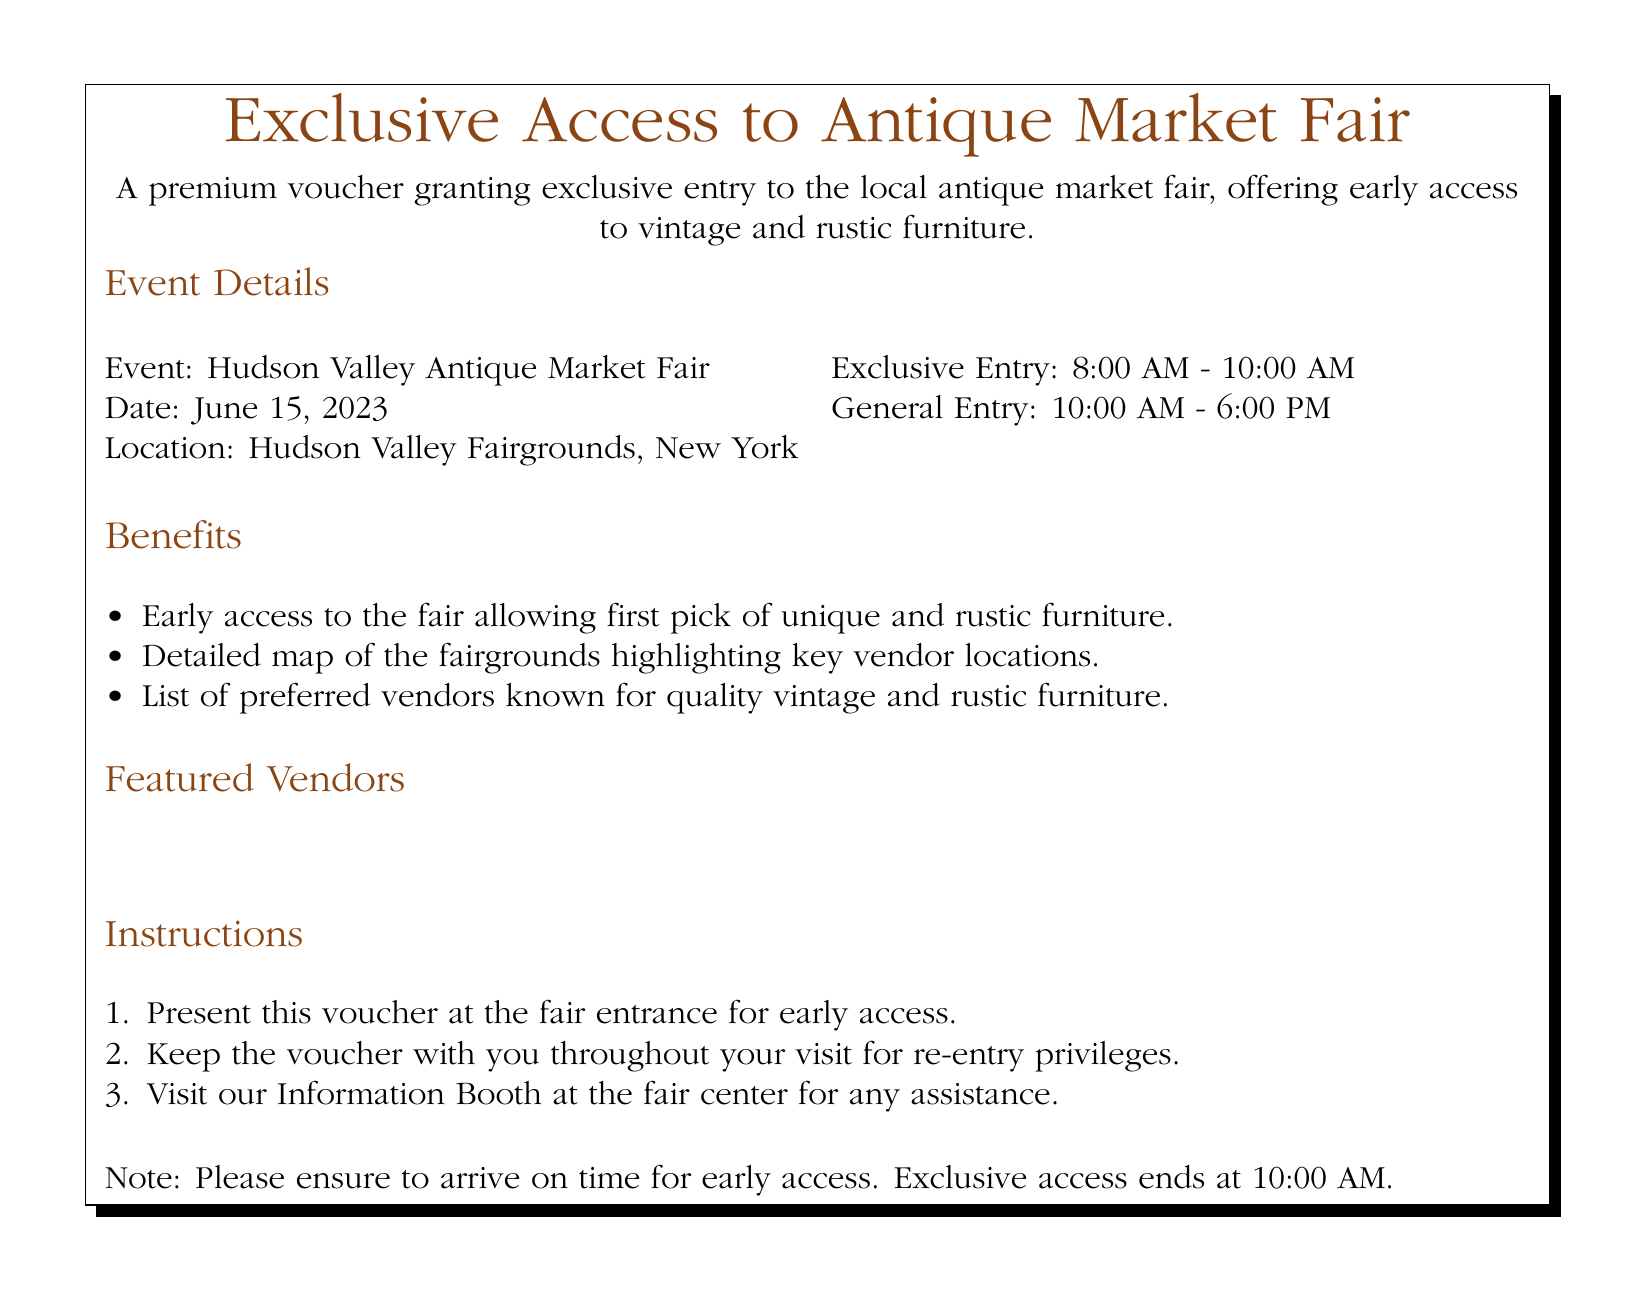What is the event name? The event name is clearly stated in the document as the "Hudson Valley Antique Market Fair."
Answer: Hudson Valley Antique Market Fair What is the location of the fair? The document specifies that the location is "Hudson Valley Fairgrounds, New York."
Answer: Hudson Valley Fairgrounds, New York What time does exclusive entry begin? The voucher states that exclusive entry starts at "8:00 AM."
Answer: 8:00 AM How long does the exclusive access last? The document mentions that exclusive access ends at "10:00 AM," meaning it lasts for 2 hours.
Answer: 2 hours Which vendor specializes in reclaimed wood furniture? The document names "Rustic Revival" as the vendor specializing in reclaimed wood furniture.
Answer: Rustic Revival What should you bring to the fair for early access? The instructions indicate that you should present "this voucher" at the fair entrance for early access.
Answer: this voucher How many featured vendors are listed? The document contains a list of four featured vendors.
Answer: Four What is the date of the event? The event date is specified as "June 15, 2023."
Answer: June 15, 2023 What is one of the benefits of the voucher? One of the benefits mentioned is "early access to the fair allowing first pick of unique and rustic furniture."
Answer: early access to the fair 